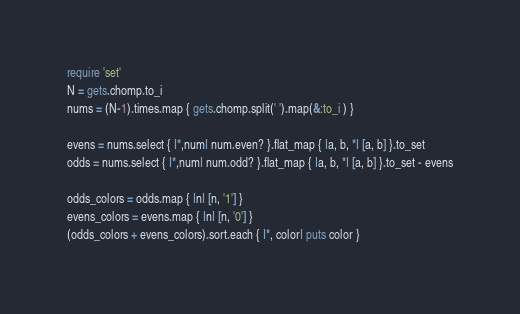<code> <loc_0><loc_0><loc_500><loc_500><_Ruby_>require 'set'
N = gets.chomp.to_i
nums = (N-1).times.map { gets.chomp.split(' ').map(&:to_i ) }

evens = nums.select { |*,num| num.even? }.flat_map { |a, b, *| [a, b] }.to_set
odds = nums.select { |*,num| num.odd? }.flat_map { |a, b, *| [a, b] }.to_set - evens

odds_colors = odds.map { |n| [n, '1'] }
evens_colors = evens.map { |n| [n, '0'] }
(odds_colors + evens_colors).sort.each { |*, color| puts color }</code> 